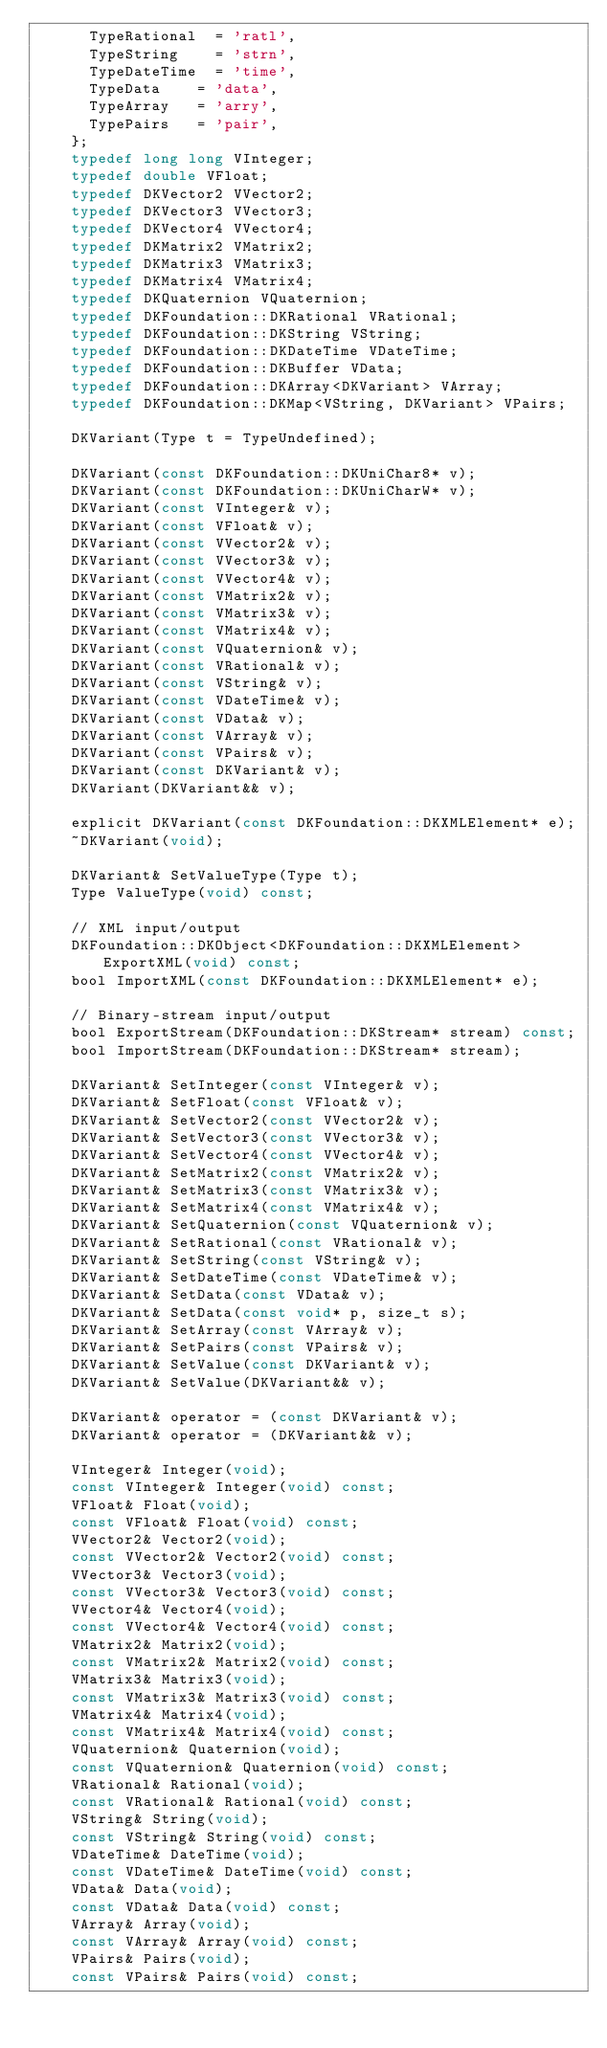Convert code to text. <code><loc_0><loc_0><loc_500><loc_500><_C_>			TypeRational	= 'ratl',
			TypeString		= 'strn',
			TypeDateTime	= 'time',
			TypeData		= 'data',
			TypeArray		= 'arry',
			TypePairs		= 'pair',
		};
		typedef long long VInteger;
		typedef double VFloat;
		typedef DKVector2 VVector2;
		typedef DKVector3 VVector3;
		typedef DKVector4 VVector4;
		typedef DKMatrix2 VMatrix2;
		typedef DKMatrix3 VMatrix3;
		typedef DKMatrix4 VMatrix4;
		typedef DKQuaternion VQuaternion;
		typedef DKFoundation::DKRational VRational;
		typedef DKFoundation::DKString VString;
		typedef DKFoundation::DKDateTime VDateTime;
		typedef DKFoundation::DKBuffer VData;
		typedef DKFoundation::DKArray<DKVariant> VArray;
		typedef DKFoundation::DKMap<VString, DKVariant> VPairs;

		DKVariant(Type t = TypeUndefined);

		DKVariant(const DKFoundation::DKUniChar8* v);
		DKVariant(const DKFoundation::DKUniCharW* v);
		DKVariant(const VInteger& v);
		DKVariant(const VFloat& v);
		DKVariant(const VVector2& v);
		DKVariant(const VVector3& v);
		DKVariant(const VVector4& v);
		DKVariant(const VMatrix2& v);
		DKVariant(const VMatrix3& v);
		DKVariant(const VMatrix4& v);
		DKVariant(const VQuaternion& v);
		DKVariant(const VRational& v);
		DKVariant(const VString& v);
		DKVariant(const VDateTime& v);
		DKVariant(const VData& v);
		DKVariant(const VArray& v);
		DKVariant(const VPairs& v);
		DKVariant(const DKVariant& v);
		DKVariant(DKVariant&& v);

		explicit DKVariant(const DKFoundation::DKXMLElement* e);
		~DKVariant(void);

		DKVariant& SetValueType(Type t);
		Type ValueType(void) const;

		// XML input/output
		DKFoundation::DKObject<DKFoundation::DKXMLElement> ExportXML(void) const;
		bool ImportXML(const DKFoundation::DKXMLElement* e);

		// Binary-stream input/output
		bool ExportStream(DKFoundation::DKStream* stream) const;
		bool ImportStream(DKFoundation::DKStream* stream);

		DKVariant& SetInteger(const VInteger& v);
		DKVariant& SetFloat(const VFloat& v);
		DKVariant& SetVector2(const VVector2& v);
		DKVariant& SetVector3(const VVector3& v);
		DKVariant& SetVector4(const VVector4& v);
		DKVariant& SetMatrix2(const VMatrix2& v);
		DKVariant& SetMatrix3(const VMatrix3& v);
		DKVariant& SetMatrix4(const VMatrix4& v);
		DKVariant& SetQuaternion(const VQuaternion& v);
		DKVariant& SetRational(const VRational& v);
		DKVariant& SetString(const VString& v);
		DKVariant& SetDateTime(const VDateTime& v);
		DKVariant& SetData(const VData& v);
		DKVariant& SetData(const void* p, size_t s);
		DKVariant& SetArray(const VArray& v);
		DKVariant& SetPairs(const VPairs& v);
		DKVariant& SetValue(const DKVariant& v);
		DKVariant& SetValue(DKVariant&& v);

		DKVariant& operator = (const DKVariant& v);
		DKVariant& operator = (DKVariant&& v);

		VInteger& Integer(void);
		const VInteger& Integer(void) const;
		VFloat& Float(void);
		const VFloat& Float(void) const;
		VVector2& Vector2(void);
		const VVector2& Vector2(void) const;
		VVector3& Vector3(void);
		const VVector3& Vector3(void) const;
		VVector4& Vector4(void);
		const VVector4& Vector4(void) const;
		VMatrix2& Matrix2(void);
		const VMatrix2& Matrix2(void) const;
		VMatrix3& Matrix3(void);
		const VMatrix3& Matrix3(void) const;
		VMatrix4& Matrix4(void);
		const VMatrix4& Matrix4(void) const;
		VQuaternion& Quaternion(void);
		const VQuaternion& Quaternion(void) const;
		VRational& Rational(void);
		const VRational& Rational(void) const;
		VString& String(void);
		const VString& String(void) const;
		VDateTime& DateTime(void);
		const VDateTime& DateTime(void) const;
		VData& Data(void);
		const VData& Data(void) const;
		VArray& Array(void);
		const VArray& Array(void) const;
		VPairs& Pairs(void);
		const VPairs& Pairs(void) const;
</code> 